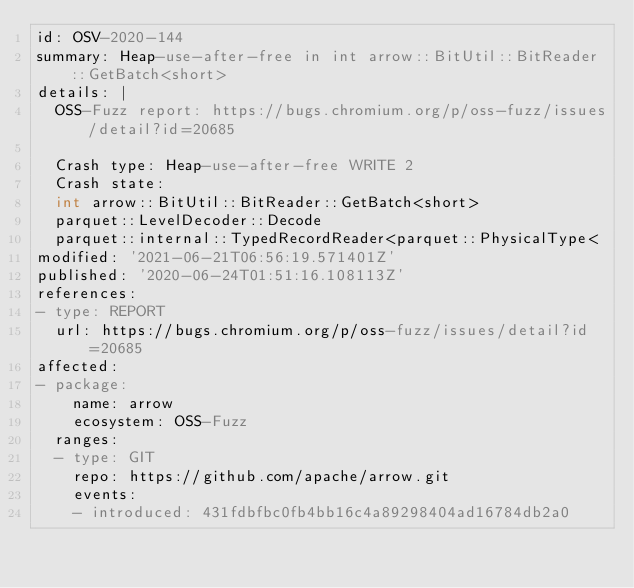<code> <loc_0><loc_0><loc_500><loc_500><_YAML_>id: OSV-2020-144
summary: Heap-use-after-free in int arrow::BitUtil::BitReader::GetBatch<short>
details: |
  OSS-Fuzz report: https://bugs.chromium.org/p/oss-fuzz/issues/detail?id=20685

  Crash type: Heap-use-after-free WRITE 2
  Crash state:
  int arrow::BitUtil::BitReader::GetBatch<short>
  parquet::LevelDecoder::Decode
  parquet::internal::TypedRecordReader<parquet::PhysicalType<
modified: '2021-06-21T06:56:19.571401Z'
published: '2020-06-24T01:51:16.108113Z'
references:
- type: REPORT
  url: https://bugs.chromium.org/p/oss-fuzz/issues/detail?id=20685
affected:
- package:
    name: arrow
    ecosystem: OSS-Fuzz
  ranges:
  - type: GIT
    repo: https://github.com/apache/arrow.git
    events:
    - introduced: 431fdbfbc0fb4bb16c4a89298404ad16784db2a0</code> 